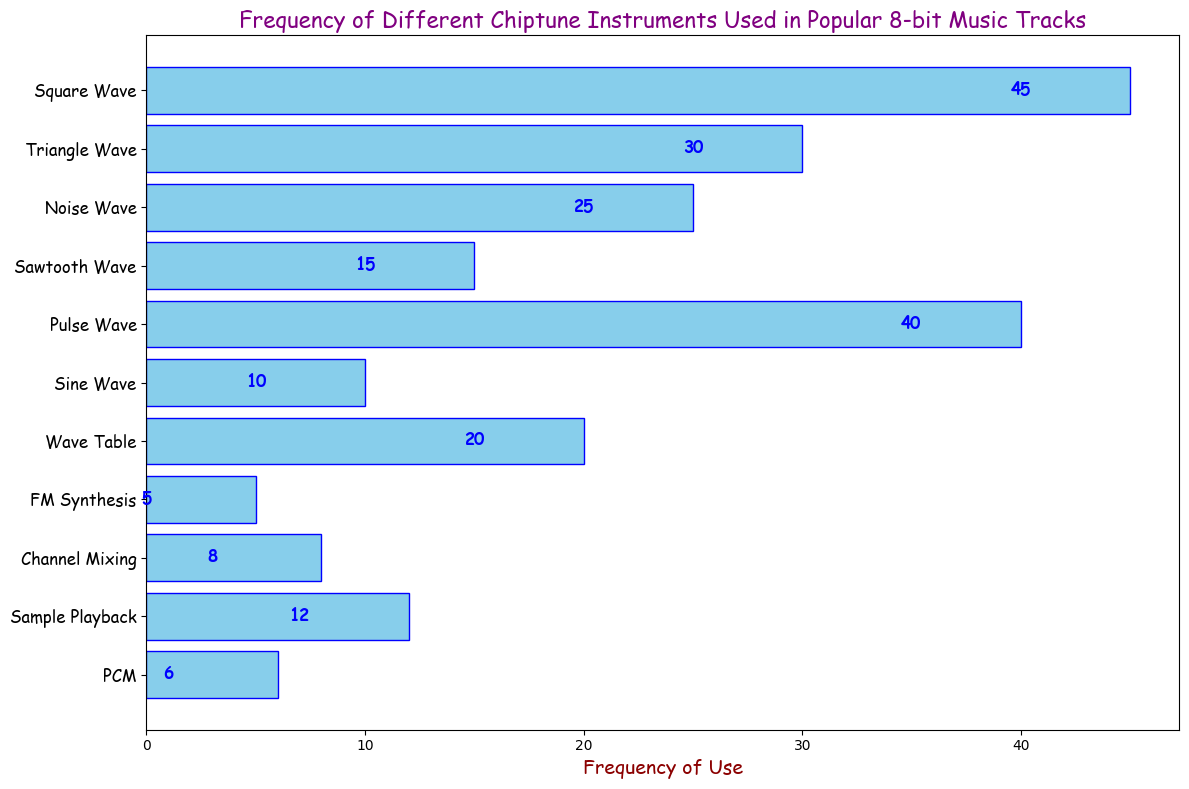What is the most frequently used chiptune instrument? The most frequently used instrument is represented by the longest bar in the histogram. The "Square Wave" bar is the longest, indicating it is used the most.
Answer: Square Wave Which instrument is used more often, Pulse Wave or Triangle Wave? Compare the lengths of the "Pulse Wave" bar and the "Triangle Wave" bar. The "Pulse Wave" bar is longer than the "Triangle Wave" bar.
Answer: Pulse Wave What is the combined frequency of use for Noise Wave and Sawtooth Wave? Find the frequencies of "Noise Wave" (25) and "Sawtooth Wave" (15) on the histogram. Add them together: 25 + 15 = 40.
Answer: 40 How many instruments are used less frequently than Wave Table? Look at the bars with frequencies less than "Wave Table" (20). These are "Sample Playback" (12), "PCM" (6), "FM Synthesis" (5), and "Channel Mixing" (8). Count them (4).
Answer: 4 Which instrument has a frequency of use equal to 10? Identify the bar with the frequency of 10. The "Sine Wave" bar matches this criterion.
Answer: Sine Wave What is the average frequency of the top three most used instruments? Identify the top three instruments by frequency: "Square Wave" (45), "Pulse Wave" (40), and "Triangle Wave" (30). Calculate the average: (45 + 40 + 30) / 3 = 115 / 3 ≈ 38.33.
Answer: 38.33 What is the difference in frequency between Sample Playback and Channel Mixing? Find the frequencies of "Sample Playback" (12) and "Channel Mixing" (8). Subtract them: 12 - 8 = 4.
Answer: 4 Which instruments are represented by blue bars in the histogram? All bars are in the color "skyblue" with blue edges, representing all shown instruments.
Answer: All instruments What is the median frequency of use for all instruments listed? Arrange the frequencies in ascending order: 5, 6, 8, 10, 12, 15, 20, 25, 30, 40, 45. The median frequency is the middle value: 15 (Sawtooth Wave).
Answer: 15 Is the frequency of the least used instrument more or less than 10? The least used instrument is "FM Synthesis" with a frequency of 5, which is less than 10.
Answer: Less 